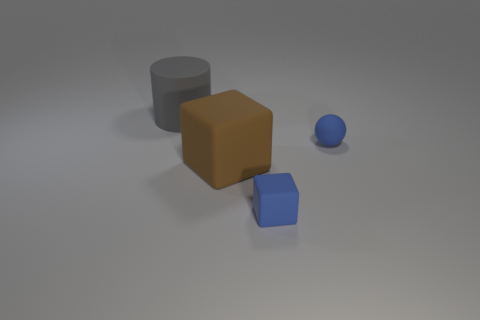Add 1 big gray matte cylinders. How many objects exist? 5 Subtract all spheres. How many objects are left? 3 Add 2 brown rubber spheres. How many brown rubber spheres exist? 2 Subtract 0 cyan cubes. How many objects are left? 4 Subtract all purple matte cylinders. Subtract all rubber balls. How many objects are left? 3 Add 3 small rubber blocks. How many small rubber blocks are left? 4 